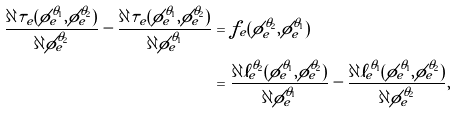<formula> <loc_0><loc_0><loc_500><loc_500>\frac { \partial \tilde { \tau } _ { e } ( \phi _ { e } ^ { \theta _ { 1 } } , \phi _ { e } ^ { \theta _ { 2 } } ) } { \partial \phi _ { e } ^ { \theta _ { 2 } } } - \frac { \partial \tilde { \tau } _ { e } ( \phi _ { e } ^ { \theta _ { 1 } } , \phi _ { e } ^ { \theta _ { 2 } } ) } { \partial \phi _ { e } ^ { \theta _ { 1 } } } & = f _ { e } ( \phi _ { e } ^ { \theta _ { 2 } } , \phi _ { e } ^ { \theta _ { 1 } } ) \\ & = \frac { \partial \tilde { \ell } _ { e } ^ { \theta _ { 2 } } ( \phi _ { e } ^ { \theta _ { 1 } } , \phi _ { e } ^ { \theta _ { 2 } } ) } { \partial \phi _ { e } ^ { \theta _ { 1 } } } - \frac { \partial \tilde { \ell } _ { e } ^ { \theta _ { 1 } } ( \phi _ { e } ^ { \theta _ { 1 } } , \phi _ { e } ^ { \theta _ { 2 } } ) } { \partial \phi _ { e } ^ { \theta _ { 2 } } } ,</formula> 